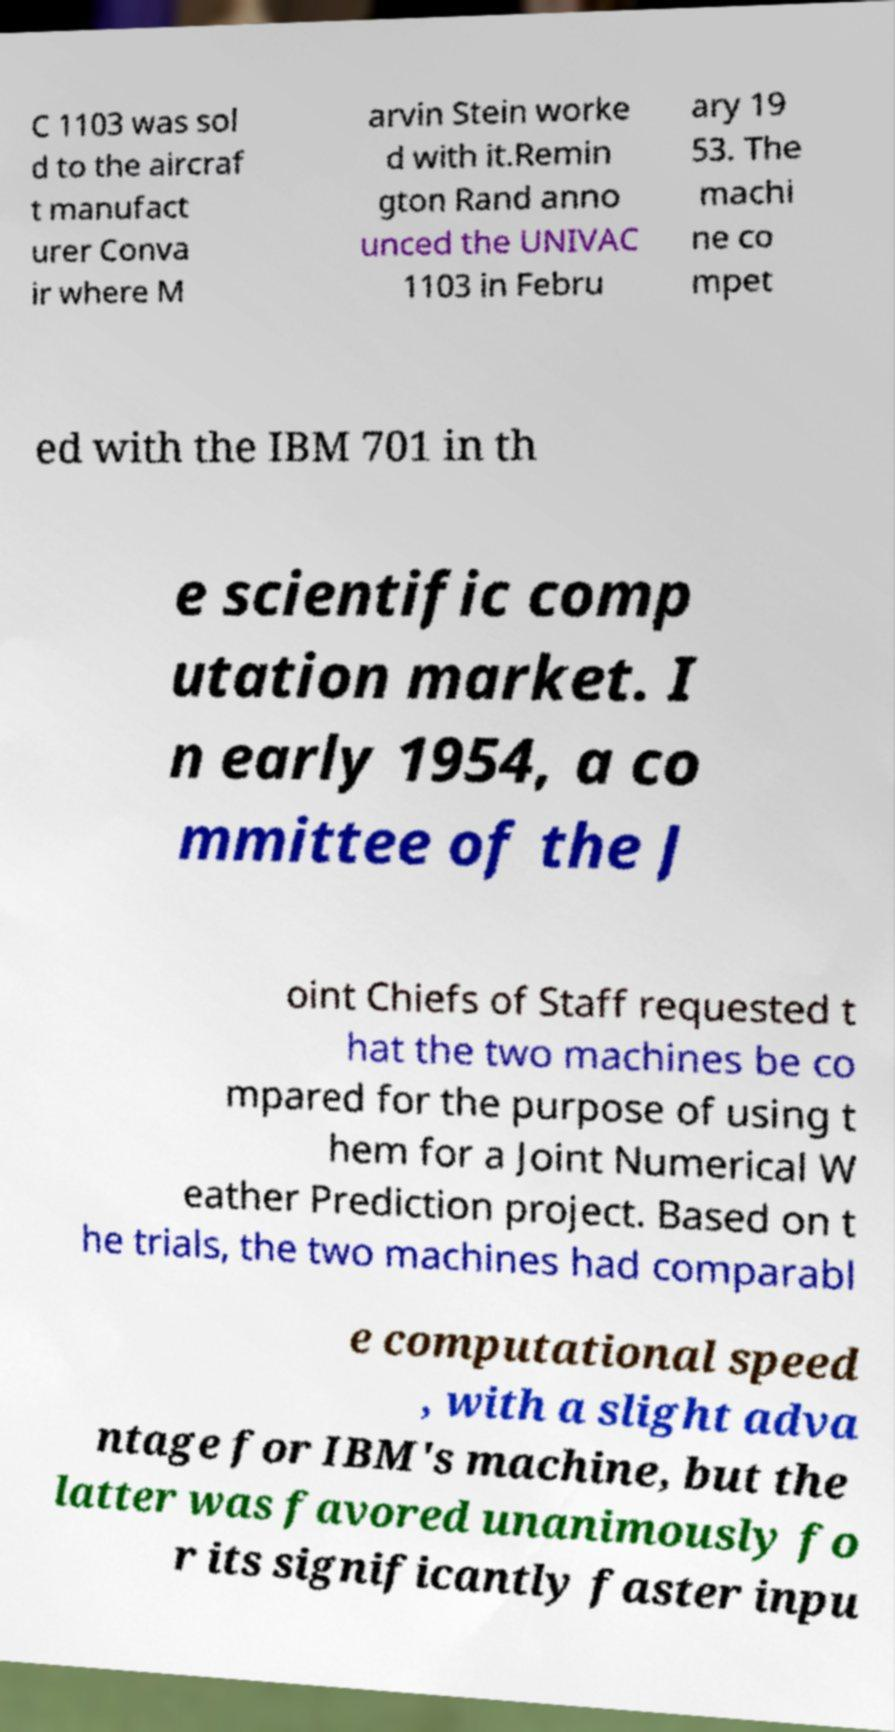Please read and relay the text visible in this image. What does it say? C 1103 was sol d to the aircraf t manufact urer Conva ir where M arvin Stein worke d with it.Remin gton Rand anno unced the UNIVAC 1103 in Febru ary 19 53. The machi ne co mpet ed with the IBM 701 in th e scientific comp utation market. I n early 1954, a co mmittee of the J oint Chiefs of Staff requested t hat the two machines be co mpared for the purpose of using t hem for a Joint Numerical W eather Prediction project. Based on t he trials, the two machines had comparabl e computational speed , with a slight adva ntage for IBM's machine, but the latter was favored unanimously fo r its significantly faster inpu 